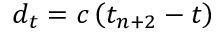Convert formula to latex. <formula><loc_0><loc_0><loc_500><loc_500>d _ { t } = c \left ( t _ { n + 2 } - t \right )</formula> 